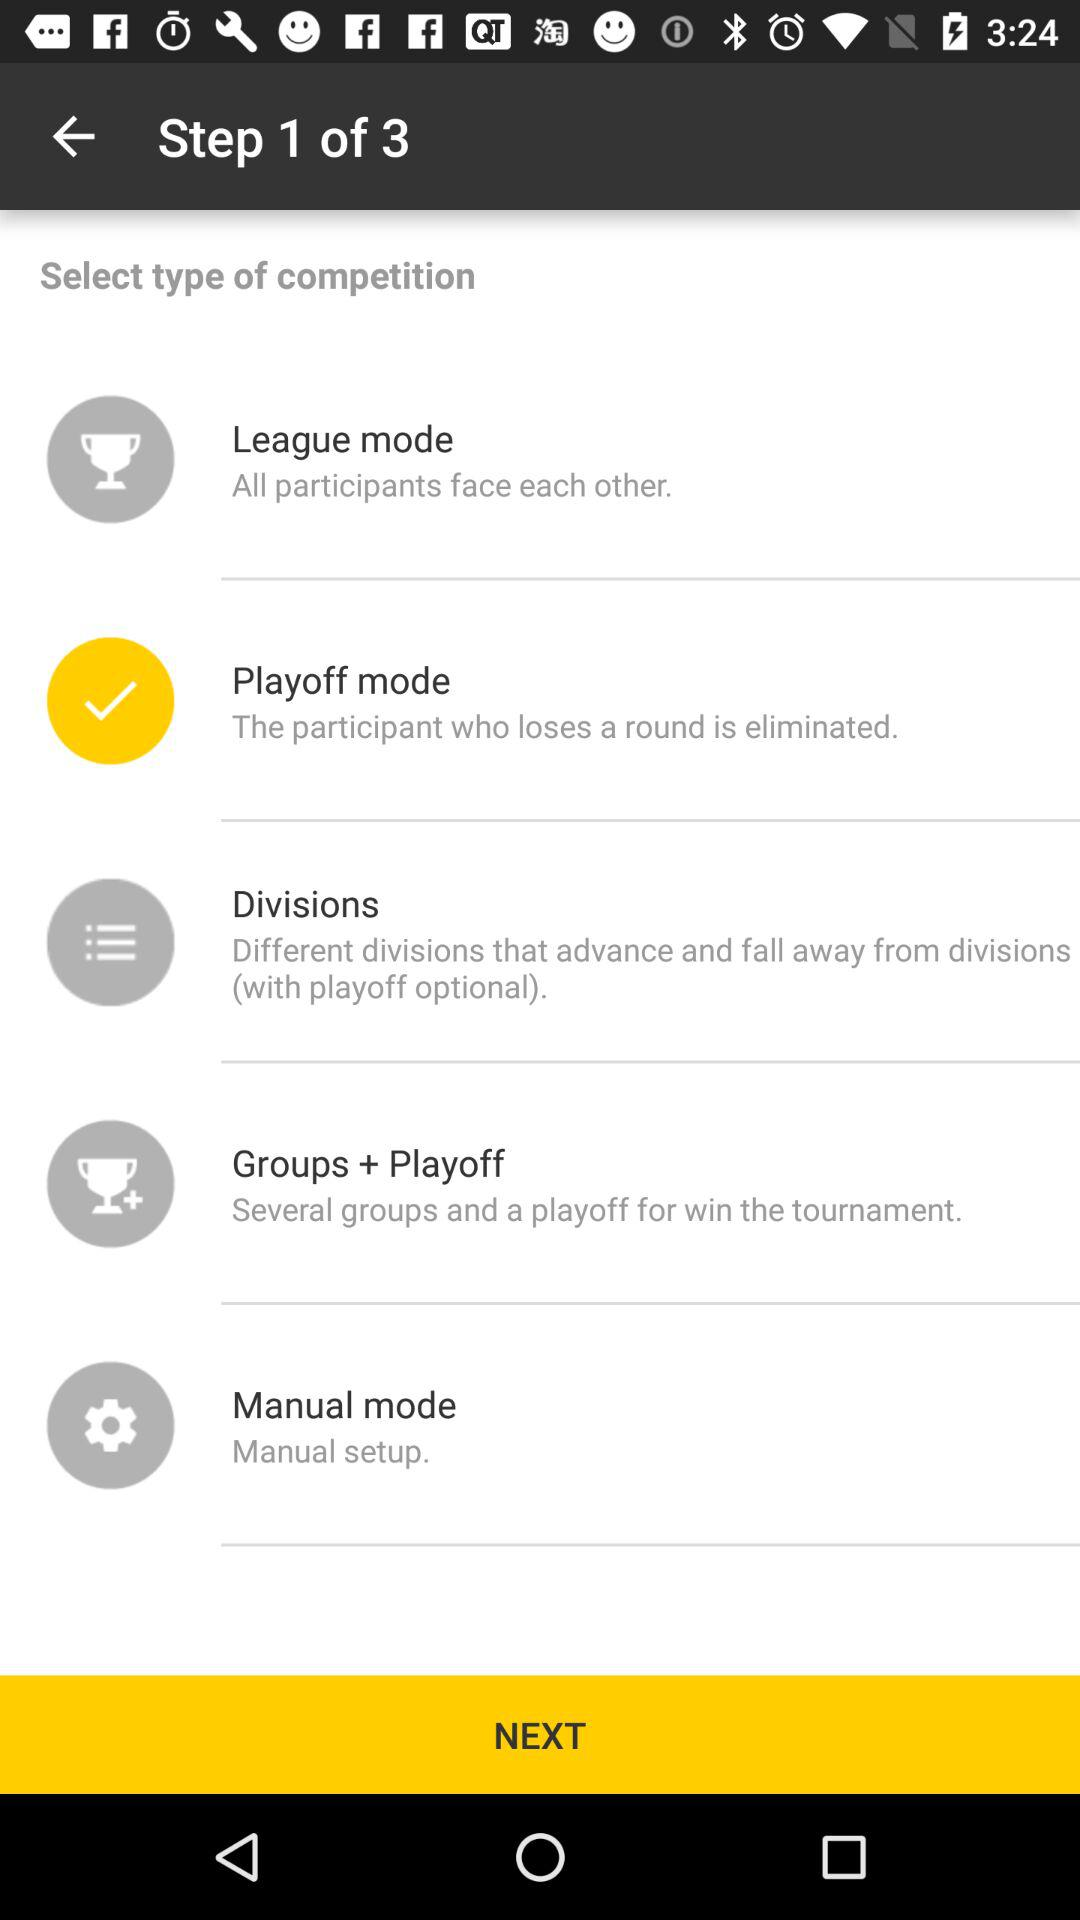How many different types of competition modes are there?
Answer the question using a single word or phrase. 5 